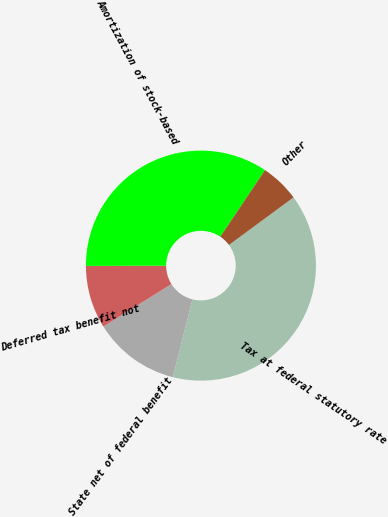Convert chart to OTSL. <chart><loc_0><loc_0><loc_500><loc_500><pie_chart><fcel>Tax at federal statutory rate<fcel>State net of federal benefit<fcel>Deferred tax benefit not<fcel>Amortization of stock-based<fcel>Other<nl><fcel>39.04%<fcel>12.19%<fcel>8.84%<fcel>34.44%<fcel>5.49%<nl></chart> 